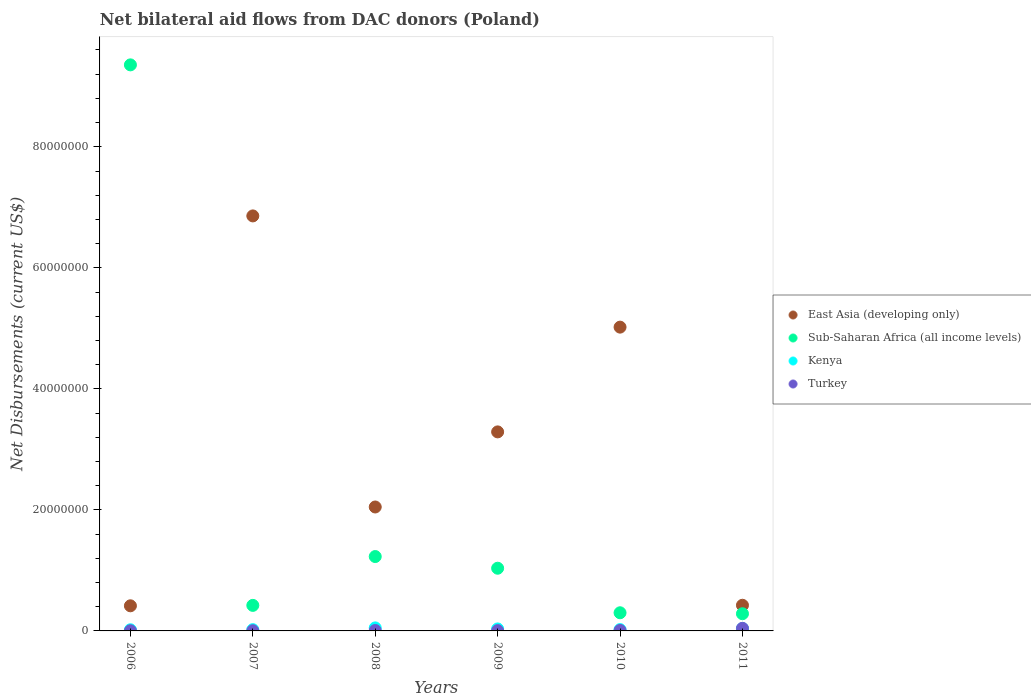How many different coloured dotlines are there?
Ensure brevity in your answer.  4. Is the number of dotlines equal to the number of legend labels?
Make the answer very short. Yes. What is the net bilateral aid flows in Turkey in 2011?
Provide a succinct answer. 4.30e+05. Across all years, what is the maximum net bilateral aid flows in Kenya?
Give a very brief answer. 5.00e+05. Across all years, what is the minimum net bilateral aid flows in East Asia (developing only)?
Provide a succinct answer. 4.15e+06. In which year was the net bilateral aid flows in Kenya maximum?
Ensure brevity in your answer.  2008. In which year was the net bilateral aid flows in East Asia (developing only) minimum?
Give a very brief answer. 2006. What is the total net bilateral aid flows in Turkey in the graph?
Make the answer very short. 6.90e+05. What is the difference between the net bilateral aid flows in Kenya in 2006 and that in 2011?
Offer a very short reply. -2.10e+05. What is the difference between the net bilateral aid flows in Kenya in 2011 and the net bilateral aid flows in Sub-Saharan Africa (all income levels) in 2009?
Your response must be concise. -9.96e+06. What is the average net bilateral aid flows in East Asia (developing only) per year?
Offer a very short reply. 3.01e+07. In the year 2007, what is the difference between the net bilateral aid flows in Turkey and net bilateral aid flows in Sub-Saharan Africa (all income levels)?
Your answer should be very brief. -4.19e+06. In how many years, is the net bilateral aid flows in Kenya greater than 20000000 US$?
Ensure brevity in your answer.  0. What is the ratio of the net bilateral aid flows in Kenya in 2006 to that in 2010?
Offer a terse response. 0.86. Is the net bilateral aid flows in Kenya in 2007 less than that in 2008?
Ensure brevity in your answer.  Yes. What is the difference between the highest and the lowest net bilateral aid flows in Kenya?
Ensure brevity in your answer.  3.10e+05. In how many years, is the net bilateral aid flows in Sub-Saharan Africa (all income levels) greater than the average net bilateral aid flows in Sub-Saharan Africa (all income levels) taken over all years?
Provide a succinct answer. 1. Is the sum of the net bilateral aid flows in Kenya in 2008 and 2009 greater than the maximum net bilateral aid flows in Turkey across all years?
Provide a succinct answer. Yes. Is the net bilateral aid flows in Kenya strictly less than the net bilateral aid flows in East Asia (developing only) over the years?
Provide a succinct answer. Yes. How many dotlines are there?
Provide a short and direct response. 4. How many years are there in the graph?
Ensure brevity in your answer.  6. Are the values on the major ticks of Y-axis written in scientific E-notation?
Give a very brief answer. No. Does the graph contain grids?
Your answer should be compact. No. Where does the legend appear in the graph?
Your answer should be very brief. Center right. What is the title of the graph?
Offer a very short reply. Net bilateral aid flows from DAC donors (Poland). What is the label or title of the X-axis?
Make the answer very short. Years. What is the label or title of the Y-axis?
Make the answer very short. Net Disbursements (current US$). What is the Net Disbursements (current US$) of East Asia (developing only) in 2006?
Keep it short and to the point. 4.15e+06. What is the Net Disbursements (current US$) in Sub-Saharan Africa (all income levels) in 2006?
Make the answer very short. 9.35e+07. What is the Net Disbursements (current US$) of Turkey in 2006?
Your response must be concise. 3.00e+04. What is the Net Disbursements (current US$) of East Asia (developing only) in 2007?
Give a very brief answer. 6.86e+07. What is the Net Disbursements (current US$) of Sub-Saharan Africa (all income levels) in 2007?
Keep it short and to the point. 4.22e+06. What is the Net Disbursements (current US$) of East Asia (developing only) in 2008?
Ensure brevity in your answer.  2.05e+07. What is the Net Disbursements (current US$) in Sub-Saharan Africa (all income levels) in 2008?
Offer a very short reply. 1.23e+07. What is the Net Disbursements (current US$) of Kenya in 2008?
Keep it short and to the point. 5.00e+05. What is the Net Disbursements (current US$) in Turkey in 2008?
Provide a short and direct response. 7.00e+04. What is the Net Disbursements (current US$) in East Asia (developing only) in 2009?
Keep it short and to the point. 3.29e+07. What is the Net Disbursements (current US$) in Sub-Saharan Africa (all income levels) in 2009?
Your response must be concise. 1.04e+07. What is the Net Disbursements (current US$) in Kenya in 2009?
Your answer should be compact. 3.30e+05. What is the Net Disbursements (current US$) of East Asia (developing only) in 2010?
Provide a succinct answer. 5.02e+07. What is the Net Disbursements (current US$) of Kenya in 2010?
Offer a very short reply. 2.20e+05. What is the Net Disbursements (current US$) of Turkey in 2010?
Keep it short and to the point. 8.00e+04. What is the Net Disbursements (current US$) of East Asia (developing only) in 2011?
Give a very brief answer. 4.24e+06. What is the Net Disbursements (current US$) of Sub-Saharan Africa (all income levels) in 2011?
Give a very brief answer. 2.84e+06. Across all years, what is the maximum Net Disbursements (current US$) of East Asia (developing only)?
Offer a terse response. 6.86e+07. Across all years, what is the maximum Net Disbursements (current US$) in Sub-Saharan Africa (all income levels)?
Give a very brief answer. 9.35e+07. Across all years, what is the maximum Net Disbursements (current US$) in Kenya?
Your answer should be very brief. 5.00e+05. Across all years, what is the maximum Net Disbursements (current US$) in Turkey?
Your response must be concise. 4.30e+05. Across all years, what is the minimum Net Disbursements (current US$) in East Asia (developing only)?
Give a very brief answer. 4.15e+06. Across all years, what is the minimum Net Disbursements (current US$) in Sub-Saharan Africa (all income levels)?
Offer a very short reply. 2.84e+06. Across all years, what is the minimum Net Disbursements (current US$) in Turkey?
Give a very brief answer. 3.00e+04. What is the total Net Disbursements (current US$) in East Asia (developing only) in the graph?
Your answer should be compact. 1.81e+08. What is the total Net Disbursements (current US$) in Sub-Saharan Africa (all income levels) in the graph?
Provide a short and direct response. 1.26e+08. What is the total Net Disbursements (current US$) in Kenya in the graph?
Offer a terse response. 1.85e+06. What is the total Net Disbursements (current US$) of Turkey in the graph?
Your response must be concise. 6.90e+05. What is the difference between the Net Disbursements (current US$) of East Asia (developing only) in 2006 and that in 2007?
Your answer should be very brief. -6.44e+07. What is the difference between the Net Disbursements (current US$) in Sub-Saharan Africa (all income levels) in 2006 and that in 2007?
Keep it short and to the point. 8.93e+07. What is the difference between the Net Disbursements (current US$) in Turkey in 2006 and that in 2007?
Make the answer very short. 0. What is the difference between the Net Disbursements (current US$) in East Asia (developing only) in 2006 and that in 2008?
Keep it short and to the point. -1.63e+07. What is the difference between the Net Disbursements (current US$) in Sub-Saharan Africa (all income levels) in 2006 and that in 2008?
Keep it short and to the point. 8.12e+07. What is the difference between the Net Disbursements (current US$) in Kenya in 2006 and that in 2008?
Make the answer very short. -3.10e+05. What is the difference between the Net Disbursements (current US$) of Turkey in 2006 and that in 2008?
Ensure brevity in your answer.  -4.00e+04. What is the difference between the Net Disbursements (current US$) in East Asia (developing only) in 2006 and that in 2009?
Your answer should be compact. -2.87e+07. What is the difference between the Net Disbursements (current US$) in Sub-Saharan Africa (all income levels) in 2006 and that in 2009?
Ensure brevity in your answer.  8.32e+07. What is the difference between the Net Disbursements (current US$) in Kenya in 2006 and that in 2009?
Your answer should be very brief. -1.40e+05. What is the difference between the Net Disbursements (current US$) of East Asia (developing only) in 2006 and that in 2010?
Offer a very short reply. -4.60e+07. What is the difference between the Net Disbursements (current US$) in Sub-Saharan Africa (all income levels) in 2006 and that in 2010?
Your answer should be compact. 9.05e+07. What is the difference between the Net Disbursements (current US$) of Turkey in 2006 and that in 2010?
Keep it short and to the point. -5.00e+04. What is the difference between the Net Disbursements (current US$) of Sub-Saharan Africa (all income levels) in 2006 and that in 2011?
Give a very brief answer. 9.07e+07. What is the difference between the Net Disbursements (current US$) of Kenya in 2006 and that in 2011?
Give a very brief answer. -2.10e+05. What is the difference between the Net Disbursements (current US$) of Turkey in 2006 and that in 2011?
Your answer should be very brief. -4.00e+05. What is the difference between the Net Disbursements (current US$) of East Asia (developing only) in 2007 and that in 2008?
Provide a succinct answer. 4.81e+07. What is the difference between the Net Disbursements (current US$) in Sub-Saharan Africa (all income levels) in 2007 and that in 2008?
Keep it short and to the point. -8.07e+06. What is the difference between the Net Disbursements (current US$) of Turkey in 2007 and that in 2008?
Keep it short and to the point. -4.00e+04. What is the difference between the Net Disbursements (current US$) in East Asia (developing only) in 2007 and that in 2009?
Provide a succinct answer. 3.57e+07. What is the difference between the Net Disbursements (current US$) in Sub-Saharan Africa (all income levels) in 2007 and that in 2009?
Give a very brief answer. -6.14e+06. What is the difference between the Net Disbursements (current US$) in Turkey in 2007 and that in 2009?
Keep it short and to the point. -2.00e+04. What is the difference between the Net Disbursements (current US$) in East Asia (developing only) in 2007 and that in 2010?
Your response must be concise. 1.84e+07. What is the difference between the Net Disbursements (current US$) in Sub-Saharan Africa (all income levels) in 2007 and that in 2010?
Your answer should be very brief. 1.22e+06. What is the difference between the Net Disbursements (current US$) of Kenya in 2007 and that in 2010?
Provide a succinct answer. -10000. What is the difference between the Net Disbursements (current US$) of Turkey in 2007 and that in 2010?
Provide a short and direct response. -5.00e+04. What is the difference between the Net Disbursements (current US$) of East Asia (developing only) in 2007 and that in 2011?
Offer a terse response. 6.43e+07. What is the difference between the Net Disbursements (current US$) of Sub-Saharan Africa (all income levels) in 2007 and that in 2011?
Your response must be concise. 1.38e+06. What is the difference between the Net Disbursements (current US$) of Kenya in 2007 and that in 2011?
Your answer should be compact. -1.90e+05. What is the difference between the Net Disbursements (current US$) of Turkey in 2007 and that in 2011?
Provide a short and direct response. -4.00e+05. What is the difference between the Net Disbursements (current US$) of East Asia (developing only) in 2008 and that in 2009?
Keep it short and to the point. -1.24e+07. What is the difference between the Net Disbursements (current US$) of Sub-Saharan Africa (all income levels) in 2008 and that in 2009?
Your answer should be compact. 1.93e+06. What is the difference between the Net Disbursements (current US$) in East Asia (developing only) in 2008 and that in 2010?
Make the answer very short. -2.97e+07. What is the difference between the Net Disbursements (current US$) of Sub-Saharan Africa (all income levels) in 2008 and that in 2010?
Your answer should be compact. 9.29e+06. What is the difference between the Net Disbursements (current US$) of East Asia (developing only) in 2008 and that in 2011?
Ensure brevity in your answer.  1.62e+07. What is the difference between the Net Disbursements (current US$) in Sub-Saharan Africa (all income levels) in 2008 and that in 2011?
Your answer should be very brief. 9.45e+06. What is the difference between the Net Disbursements (current US$) in Kenya in 2008 and that in 2011?
Offer a very short reply. 1.00e+05. What is the difference between the Net Disbursements (current US$) in Turkey in 2008 and that in 2011?
Offer a very short reply. -3.60e+05. What is the difference between the Net Disbursements (current US$) of East Asia (developing only) in 2009 and that in 2010?
Keep it short and to the point. -1.73e+07. What is the difference between the Net Disbursements (current US$) in Sub-Saharan Africa (all income levels) in 2009 and that in 2010?
Offer a terse response. 7.36e+06. What is the difference between the Net Disbursements (current US$) of Kenya in 2009 and that in 2010?
Keep it short and to the point. 1.10e+05. What is the difference between the Net Disbursements (current US$) in Turkey in 2009 and that in 2010?
Offer a terse response. -3.00e+04. What is the difference between the Net Disbursements (current US$) of East Asia (developing only) in 2009 and that in 2011?
Provide a short and direct response. 2.86e+07. What is the difference between the Net Disbursements (current US$) in Sub-Saharan Africa (all income levels) in 2009 and that in 2011?
Give a very brief answer. 7.52e+06. What is the difference between the Net Disbursements (current US$) of Turkey in 2009 and that in 2011?
Give a very brief answer. -3.80e+05. What is the difference between the Net Disbursements (current US$) of East Asia (developing only) in 2010 and that in 2011?
Offer a terse response. 4.60e+07. What is the difference between the Net Disbursements (current US$) of Kenya in 2010 and that in 2011?
Provide a succinct answer. -1.80e+05. What is the difference between the Net Disbursements (current US$) of Turkey in 2010 and that in 2011?
Your answer should be compact. -3.50e+05. What is the difference between the Net Disbursements (current US$) in East Asia (developing only) in 2006 and the Net Disbursements (current US$) in Kenya in 2007?
Give a very brief answer. 3.94e+06. What is the difference between the Net Disbursements (current US$) of East Asia (developing only) in 2006 and the Net Disbursements (current US$) of Turkey in 2007?
Ensure brevity in your answer.  4.12e+06. What is the difference between the Net Disbursements (current US$) in Sub-Saharan Africa (all income levels) in 2006 and the Net Disbursements (current US$) in Kenya in 2007?
Offer a terse response. 9.33e+07. What is the difference between the Net Disbursements (current US$) in Sub-Saharan Africa (all income levels) in 2006 and the Net Disbursements (current US$) in Turkey in 2007?
Offer a terse response. 9.35e+07. What is the difference between the Net Disbursements (current US$) of Kenya in 2006 and the Net Disbursements (current US$) of Turkey in 2007?
Offer a very short reply. 1.60e+05. What is the difference between the Net Disbursements (current US$) of East Asia (developing only) in 2006 and the Net Disbursements (current US$) of Sub-Saharan Africa (all income levels) in 2008?
Offer a terse response. -8.14e+06. What is the difference between the Net Disbursements (current US$) of East Asia (developing only) in 2006 and the Net Disbursements (current US$) of Kenya in 2008?
Provide a succinct answer. 3.65e+06. What is the difference between the Net Disbursements (current US$) of East Asia (developing only) in 2006 and the Net Disbursements (current US$) of Turkey in 2008?
Your answer should be compact. 4.08e+06. What is the difference between the Net Disbursements (current US$) of Sub-Saharan Africa (all income levels) in 2006 and the Net Disbursements (current US$) of Kenya in 2008?
Ensure brevity in your answer.  9.30e+07. What is the difference between the Net Disbursements (current US$) in Sub-Saharan Africa (all income levels) in 2006 and the Net Disbursements (current US$) in Turkey in 2008?
Give a very brief answer. 9.35e+07. What is the difference between the Net Disbursements (current US$) in East Asia (developing only) in 2006 and the Net Disbursements (current US$) in Sub-Saharan Africa (all income levels) in 2009?
Provide a succinct answer. -6.21e+06. What is the difference between the Net Disbursements (current US$) in East Asia (developing only) in 2006 and the Net Disbursements (current US$) in Kenya in 2009?
Offer a terse response. 3.82e+06. What is the difference between the Net Disbursements (current US$) of East Asia (developing only) in 2006 and the Net Disbursements (current US$) of Turkey in 2009?
Your answer should be very brief. 4.10e+06. What is the difference between the Net Disbursements (current US$) in Sub-Saharan Africa (all income levels) in 2006 and the Net Disbursements (current US$) in Kenya in 2009?
Your response must be concise. 9.32e+07. What is the difference between the Net Disbursements (current US$) of Sub-Saharan Africa (all income levels) in 2006 and the Net Disbursements (current US$) of Turkey in 2009?
Ensure brevity in your answer.  9.35e+07. What is the difference between the Net Disbursements (current US$) of Kenya in 2006 and the Net Disbursements (current US$) of Turkey in 2009?
Keep it short and to the point. 1.40e+05. What is the difference between the Net Disbursements (current US$) of East Asia (developing only) in 2006 and the Net Disbursements (current US$) of Sub-Saharan Africa (all income levels) in 2010?
Provide a short and direct response. 1.15e+06. What is the difference between the Net Disbursements (current US$) of East Asia (developing only) in 2006 and the Net Disbursements (current US$) of Kenya in 2010?
Provide a short and direct response. 3.93e+06. What is the difference between the Net Disbursements (current US$) in East Asia (developing only) in 2006 and the Net Disbursements (current US$) in Turkey in 2010?
Offer a terse response. 4.07e+06. What is the difference between the Net Disbursements (current US$) in Sub-Saharan Africa (all income levels) in 2006 and the Net Disbursements (current US$) in Kenya in 2010?
Make the answer very short. 9.33e+07. What is the difference between the Net Disbursements (current US$) of Sub-Saharan Africa (all income levels) in 2006 and the Net Disbursements (current US$) of Turkey in 2010?
Give a very brief answer. 9.35e+07. What is the difference between the Net Disbursements (current US$) in Kenya in 2006 and the Net Disbursements (current US$) in Turkey in 2010?
Ensure brevity in your answer.  1.10e+05. What is the difference between the Net Disbursements (current US$) in East Asia (developing only) in 2006 and the Net Disbursements (current US$) in Sub-Saharan Africa (all income levels) in 2011?
Keep it short and to the point. 1.31e+06. What is the difference between the Net Disbursements (current US$) of East Asia (developing only) in 2006 and the Net Disbursements (current US$) of Kenya in 2011?
Your answer should be compact. 3.75e+06. What is the difference between the Net Disbursements (current US$) of East Asia (developing only) in 2006 and the Net Disbursements (current US$) of Turkey in 2011?
Offer a terse response. 3.72e+06. What is the difference between the Net Disbursements (current US$) in Sub-Saharan Africa (all income levels) in 2006 and the Net Disbursements (current US$) in Kenya in 2011?
Your answer should be compact. 9.31e+07. What is the difference between the Net Disbursements (current US$) in Sub-Saharan Africa (all income levels) in 2006 and the Net Disbursements (current US$) in Turkey in 2011?
Offer a terse response. 9.31e+07. What is the difference between the Net Disbursements (current US$) in East Asia (developing only) in 2007 and the Net Disbursements (current US$) in Sub-Saharan Africa (all income levels) in 2008?
Ensure brevity in your answer.  5.63e+07. What is the difference between the Net Disbursements (current US$) of East Asia (developing only) in 2007 and the Net Disbursements (current US$) of Kenya in 2008?
Offer a terse response. 6.81e+07. What is the difference between the Net Disbursements (current US$) in East Asia (developing only) in 2007 and the Net Disbursements (current US$) in Turkey in 2008?
Your answer should be very brief. 6.85e+07. What is the difference between the Net Disbursements (current US$) of Sub-Saharan Africa (all income levels) in 2007 and the Net Disbursements (current US$) of Kenya in 2008?
Provide a short and direct response. 3.72e+06. What is the difference between the Net Disbursements (current US$) in Sub-Saharan Africa (all income levels) in 2007 and the Net Disbursements (current US$) in Turkey in 2008?
Keep it short and to the point. 4.15e+06. What is the difference between the Net Disbursements (current US$) of East Asia (developing only) in 2007 and the Net Disbursements (current US$) of Sub-Saharan Africa (all income levels) in 2009?
Ensure brevity in your answer.  5.82e+07. What is the difference between the Net Disbursements (current US$) of East Asia (developing only) in 2007 and the Net Disbursements (current US$) of Kenya in 2009?
Ensure brevity in your answer.  6.82e+07. What is the difference between the Net Disbursements (current US$) of East Asia (developing only) in 2007 and the Net Disbursements (current US$) of Turkey in 2009?
Offer a terse response. 6.85e+07. What is the difference between the Net Disbursements (current US$) in Sub-Saharan Africa (all income levels) in 2007 and the Net Disbursements (current US$) in Kenya in 2009?
Make the answer very short. 3.89e+06. What is the difference between the Net Disbursements (current US$) in Sub-Saharan Africa (all income levels) in 2007 and the Net Disbursements (current US$) in Turkey in 2009?
Your response must be concise. 4.17e+06. What is the difference between the Net Disbursements (current US$) in Kenya in 2007 and the Net Disbursements (current US$) in Turkey in 2009?
Keep it short and to the point. 1.60e+05. What is the difference between the Net Disbursements (current US$) in East Asia (developing only) in 2007 and the Net Disbursements (current US$) in Sub-Saharan Africa (all income levels) in 2010?
Offer a terse response. 6.56e+07. What is the difference between the Net Disbursements (current US$) of East Asia (developing only) in 2007 and the Net Disbursements (current US$) of Kenya in 2010?
Offer a very short reply. 6.84e+07. What is the difference between the Net Disbursements (current US$) of East Asia (developing only) in 2007 and the Net Disbursements (current US$) of Turkey in 2010?
Keep it short and to the point. 6.85e+07. What is the difference between the Net Disbursements (current US$) of Sub-Saharan Africa (all income levels) in 2007 and the Net Disbursements (current US$) of Kenya in 2010?
Offer a terse response. 4.00e+06. What is the difference between the Net Disbursements (current US$) of Sub-Saharan Africa (all income levels) in 2007 and the Net Disbursements (current US$) of Turkey in 2010?
Offer a very short reply. 4.14e+06. What is the difference between the Net Disbursements (current US$) in East Asia (developing only) in 2007 and the Net Disbursements (current US$) in Sub-Saharan Africa (all income levels) in 2011?
Offer a terse response. 6.57e+07. What is the difference between the Net Disbursements (current US$) in East Asia (developing only) in 2007 and the Net Disbursements (current US$) in Kenya in 2011?
Keep it short and to the point. 6.82e+07. What is the difference between the Net Disbursements (current US$) of East Asia (developing only) in 2007 and the Net Disbursements (current US$) of Turkey in 2011?
Keep it short and to the point. 6.82e+07. What is the difference between the Net Disbursements (current US$) in Sub-Saharan Africa (all income levels) in 2007 and the Net Disbursements (current US$) in Kenya in 2011?
Give a very brief answer. 3.82e+06. What is the difference between the Net Disbursements (current US$) in Sub-Saharan Africa (all income levels) in 2007 and the Net Disbursements (current US$) in Turkey in 2011?
Your answer should be compact. 3.79e+06. What is the difference between the Net Disbursements (current US$) in Kenya in 2007 and the Net Disbursements (current US$) in Turkey in 2011?
Give a very brief answer. -2.20e+05. What is the difference between the Net Disbursements (current US$) in East Asia (developing only) in 2008 and the Net Disbursements (current US$) in Sub-Saharan Africa (all income levels) in 2009?
Provide a short and direct response. 1.01e+07. What is the difference between the Net Disbursements (current US$) of East Asia (developing only) in 2008 and the Net Disbursements (current US$) of Kenya in 2009?
Offer a very short reply. 2.02e+07. What is the difference between the Net Disbursements (current US$) in East Asia (developing only) in 2008 and the Net Disbursements (current US$) in Turkey in 2009?
Ensure brevity in your answer.  2.04e+07. What is the difference between the Net Disbursements (current US$) of Sub-Saharan Africa (all income levels) in 2008 and the Net Disbursements (current US$) of Kenya in 2009?
Your answer should be compact. 1.20e+07. What is the difference between the Net Disbursements (current US$) of Sub-Saharan Africa (all income levels) in 2008 and the Net Disbursements (current US$) of Turkey in 2009?
Provide a succinct answer. 1.22e+07. What is the difference between the Net Disbursements (current US$) of Kenya in 2008 and the Net Disbursements (current US$) of Turkey in 2009?
Your answer should be compact. 4.50e+05. What is the difference between the Net Disbursements (current US$) in East Asia (developing only) in 2008 and the Net Disbursements (current US$) in Sub-Saharan Africa (all income levels) in 2010?
Give a very brief answer. 1.75e+07. What is the difference between the Net Disbursements (current US$) of East Asia (developing only) in 2008 and the Net Disbursements (current US$) of Kenya in 2010?
Your response must be concise. 2.03e+07. What is the difference between the Net Disbursements (current US$) of East Asia (developing only) in 2008 and the Net Disbursements (current US$) of Turkey in 2010?
Provide a short and direct response. 2.04e+07. What is the difference between the Net Disbursements (current US$) in Sub-Saharan Africa (all income levels) in 2008 and the Net Disbursements (current US$) in Kenya in 2010?
Provide a short and direct response. 1.21e+07. What is the difference between the Net Disbursements (current US$) of Sub-Saharan Africa (all income levels) in 2008 and the Net Disbursements (current US$) of Turkey in 2010?
Keep it short and to the point. 1.22e+07. What is the difference between the Net Disbursements (current US$) of Kenya in 2008 and the Net Disbursements (current US$) of Turkey in 2010?
Your answer should be compact. 4.20e+05. What is the difference between the Net Disbursements (current US$) in East Asia (developing only) in 2008 and the Net Disbursements (current US$) in Sub-Saharan Africa (all income levels) in 2011?
Offer a terse response. 1.76e+07. What is the difference between the Net Disbursements (current US$) in East Asia (developing only) in 2008 and the Net Disbursements (current US$) in Kenya in 2011?
Offer a very short reply. 2.01e+07. What is the difference between the Net Disbursements (current US$) of East Asia (developing only) in 2008 and the Net Disbursements (current US$) of Turkey in 2011?
Your answer should be very brief. 2.00e+07. What is the difference between the Net Disbursements (current US$) in Sub-Saharan Africa (all income levels) in 2008 and the Net Disbursements (current US$) in Kenya in 2011?
Give a very brief answer. 1.19e+07. What is the difference between the Net Disbursements (current US$) in Sub-Saharan Africa (all income levels) in 2008 and the Net Disbursements (current US$) in Turkey in 2011?
Your answer should be very brief. 1.19e+07. What is the difference between the Net Disbursements (current US$) of Kenya in 2008 and the Net Disbursements (current US$) of Turkey in 2011?
Your answer should be very brief. 7.00e+04. What is the difference between the Net Disbursements (current US$) of East Asia (developing only) in 2009 and the Net Disbursements (current US$) of Sub-Saharan Africa (all income levels) in 2010?
Your response must be concise. 2.99e+07. What is the difference between the Net Disbursements (current US$) in East Asia (developing only) in 2009 and the Net Disbursements (current US$) in Kenya in 2010?
Your response must be concise. 3.27e+07. What is the difference between the Net Disbursements (current US$) of East Asia (developing only) in 2009 and the Net Disbursements (current US$) of Turkey in 2010?
Your answer should be compact. 3.28e+07. What is the difference between the Net Disbursements (current US$) in Sub-Saharan Africa (all income levels) in 2009 and the Net Disbursements (current US$) in Kenya in 2010?
Ensure brevity in your answer.  1.01e+07. What is the difference between the Net Disbursements (current US$) of Sub-Saharan Africa (all income levels) in 2009 and the Net Disbursements (current US$) of Turkey in 2010?
Your response must be concise. 1.03e+07. What is the difference between the Net Disbursements (current US$) in Kenya in 2009 and the Net Disbursements (current US$) in Turkey in 2010?
Keep it short and to the point. 2.50e+05. What is the difference between the Net Disbursements (current US$) in East Asia (developing only) in 2009 and the Net Disbursements (current US$) in Sub-Saharan Africa (all income levels) in 2011?
Offer a terse response. 3.00e+07. What is the difference between the Net Disbursements (current US$) in East Asia (developing only) in 2009 and the Net Disbursements (current US$) in Kenya in 2011?
Your answer should be compact. 3.25e+07. What is the difference between the Net Disbursements (current US$) in East Asia (developing only) in 2009 and the Net Disbursements (current US$) in Turkey in 2011?
Offer a terse response. 3.25e+07. What is the difference between the Net Disbursements (current US$) in Sub-Saharan Africa (all income levels) in 2009 and the Net Disbursements (current US$) in Kenya in 2011?
Provide a succinct answer. 9.96e+06. What is the difference between the Net Disbursements (current US$) in Sub-Saharan Africa (all income levels) in 2009 and the Net Disbursements (current US$) in Turkey in 2011?
Offer a very short reply. 9.93e+06. What is the difference between the Net Disbursements (current US$) in Kenya in 2009 and the Net Disbursements (current US$) in Turkey in 2011?
Your response must be concise. -1.00e+05. What is the difference between the Net Disbursements (current US$) in East Asia (developing only) in 2010 and the Net Disbursements (current US$) in Sub-Saharan Africa (all income levels) in 2011?
Give a very brief answer. 4.74e+07. What is the difference between the Net Disbursements (current US$) of East Asia (developing only) in 2010 and the Net Disbursements (current US$) of Kenya in 2011?
Keep it short and to the point. 4.98e+07. What is the difference between the Net Disbursements (current US$) in East Asia (developing only) in 2010 and the Net Disbursements (current US$) in Turkey in 2011?
Give a very brief answer. 4.98e+07. What is the difference between the Net Disbursements (current US$) in Sub-Saharan Africa (all income levels) in 2010 and the Net Disbursements (current US$) in Kenya in 2011?
Your answer should be compact. 2.60e+06. What is the difference between the Net Disbursements (current US$) of Sub-Saharan Africa (all income levels) in 2010 and the Net Disbursements (current US$) of Turkey in 2011?
Provide a short and direct response. 2.57e+06. What is the average Net Disbursements (current US$) of East Asia (developing only) per year?
Your response must be concise. 3.01e+07. What is the average Net Disbursements (current US$) of Sub-Saharan Africa (all income levels) per year?
Provide a succinct answer. 2.10e+07. What is the average Net Disbursements (current US$) of Kenya per year?
Your response must be concise. 3.08e+05. What is the average Net Disbursements (current US$) of Turkey per year?
Offer a terse response. 1.15e+05. In the year 2006, what is the difference between the Net Disbursements (current US$) in East Asia (developing only) and Net Disbursements (current US$) in Sub-Saharan Africa (all income levels)?
Your response must be concise. -8.94e+07. In the year 2006, what is the difference between the Net Disbursements (current US$) in East Asia (developing only) and Net Disbursements (current US$) in Kenya?
Your response must be concise. 3.96e+06. In the year 2006, what is the difference between the Net Disbursements (current US$) in East Asia (developing only) and Net Disbursements (current US$) in Turkey?
Your answer should be very brief. 4.12e+06. In the year 2006, what is the difference between the Net Disbursements (current US$) in Sub-Saharan Africa (all income levels) and Net Disbursements (current US$) in Kenya?
Make the answer very short. 9.34e+07. In the year 2006, what is the difference between the Net Disbursements (current US$) in Sub-Saharan Africa (all income levels) and Net Disbursements (current US$) in Turkey?
Give a very brief answer. 9.35e+07. In the year 2007, what is the difference between the Net Disbursements (current US$) of East Asia (developing only) and Net Disbursements (current US$) of Sub-Saharan Africa (all income levels)?
Offer a very short reply. 6.44e+07. In the year 2007, what is the difference between the Net Disbursements (current US$) in East Asia (developing only) and Net Disbursements (current US$) in Kenya?
Keep it short and to the point. 6.84e+07. In the year 2007, what is the difference between the Net Disbursements (current US$) in East Asia (developing only) and Net Disbursements (current US$) in Turkey?
Offer a terse response. 6.86e+07. In the year 2007, what is the difference between the Net Disbursements (current US$) of Sub-Saharan Africa (all income levels) and Net Disbursements (current US$) of Kenya?
Ensure brevity in your answer.  4.01e+06. In the year 2007, what is the difference between the Net Disbursements (current US$) of Sub-Saharan Africa (all income levels) and Net Disbursements (current US$) of Turkey?
Offer a terse response. 4.19e+06. In the year 2008, what is the difference between the Net Disbursements (current US$) in East Asia (developing only) and Net Disbursements (current US$) in Sub-Saharan Africa (all income levels)?
Provide a short and direct response. 8.19e+06. In the year 2008, what is the difference between the Net Disbursements (current US$) in East Asia (developing only) and Net Disbursements (current US$) in Kenya?
Your response must be concise. 2.00e+07. In the year 2008, what is the difference between the Net Disbursements (current US$) in East Asia (developing only) and Net Disbursements (current US$) in Turkey?
Your answer should be very brief. 2.04e+07. In the year 2008, what is the difference between the Net Disbursements (current US$) of Sub-Saharan Africa (all income levels) and Net Disbursements (current US$) of Kenya?
Offer a very short reply. 1.18e+07. In the year 2008, what is the difference between the Net Disbursements (current US$) in Sub-Saharan Africa (all income levels) and Net Disbursements (current US$) in Turkey?
Offer a very short reply. 1.22e+07. In the year 2008, what is the difference between the Net Disbursements (current US$) of Kenya and Net Disbursements (current US$) of Turkey?
Provide a short and direct response. 4.30e+05. In the year 2009, what is the difference between the Net Disbursements (current US$) of East Asia (developing only) and Net Disbursements (current US$) of Sub-Saharan Africa (all income levels)?
Provide a short and direct response. 2.25e+07. In the year 2009, what is the difference between the Net Disbursements (current US$) of East Asia (developing only) and Net Disbursements (current US$) of Kenya?
Make the answer very short. 3.26e+07. In the year 2009, what is the difference between the Net Disbursements (current US$) of East Asia (developing only) and Net Disbursements (current US$) of Turkey?
Offer a terse response. 3.28e+07. In the year 2009, what is the difference between the Net Disbursements (current US$) in Sub-Saharan Africa (all income levels) and Net Disbursements (current US$) in Kenya?
Provide a short and direct response. 1.00e+07. In the year 2009, what is the difference between the Net Disbursements (current US$) in Sub-Saharan Africa (all income levels) and Net Disbursements (current US$) in Turkey?
Provide a short and direct response. 1.03e+07. In the year 2010, what is the difference between the Net Disbursements (current US$) in East Asia (developing only) and Net Disbursements (current US$) in Sub-Saharan Africa (all income levels)?
Make the answer very short. 4.72e+07. In the year 2010, what is the difference between the Net Disbursements (current US$) in East Asia (developing only) and Net Disbursements (current US$) in Kenya?
Ensure brevity in your answer.  5.00e+07. In the year 2010, what is the difference between the Net Disbursements (current US$) in East Asia (developing only) and Net Disbursements (current US$) in Turkey?
Your answer should be very brief. 5.01e+07. In the year 2010, what is the difference between the Net Disbursements (current US$) of Sub-Saharan Africa (all income levels) and Net Disbursements (current US$) of Kenya?
Provide a short and direct response. 2.78e+06. In the year 2010, what is the difference between the Net Disbursements (current US$) of Sub-Saharan Africa (all income levels) and Net Disbursements (current US$) of Turkey?
Offer a terse response. 2.92e+06. In the year 2010, what is the difference between the Net Disbursements (current US$) of Kenya and Net Disbursements (current US$) of Turkey?
Make the answer very short. 1.40e+05. In the year 2011, what is the difference between the Net Disbursements (current US$) in East Asia (developing only) and Net Disbursements (current US$) in Sub-Saharan Africa (all income levels)?
Provide a short and direct response. 1.40e+06. In the year 2011, what is the difference between the Net Disbursements (current US$) of East Asia (developing only) and Net Disbursements (current US$) of Kenya?
Offer a very short reply. 3.84e+06. In the year 2011, what is the difference between the Net Disbursements (current US$) in East Asia (developing only) and Net Disbursements (current US$) in Turkey?
Give a very brief answer. 3.81e+06. In the year 2011, what is the difference between the Net Disbursements (current US$) in Sub-Saharan Africa (all income levels) and Net Disbursements (current US$) in Kenya?
Provide a short and direct response. 2.44e+06. In the year 2011, what is the difference between the Net Disbursements (current US$) in Sub-Saharan Africa (all income levels) and Net Disbursements (current US$) in Turkey?
Provide a short and direct response. 2.41e+06. In the year 2011, what is the difference between the Net Disbursements (current US$) in Kenya and Net Disbursements (current US$) in Turkey?
Provide a short and direct response. -3.00e+04. What is the ratio of the Net Disbursements (current US$) in East Asia (developing only) in 2006 to that in 2007?
Give a very brief answer. 0.06. What is the ratio of the Net Disbursements (current US$) in Sub-Saharan Africa (all income levels) in 2006 to that in 2007?
Your response must be concise. 22.17. What is the ratio of the Net Disbursements (current US$) in Kenya in 2006 to that in 2007?
Give a very brief answer. 0.9. What is the ratio of the Net Disbursements (current US$) of East Asia (developing only) in 2006 to that in 2008?
Your response must be concise. 0.2. What is the ratio of the Net Disbursements (current US$) in Sub-Saharan Africa (all income levels) in 2006 to that in 2008?
Offer a terse response. 7.61. What is the ratio of the Net Disbursements (current US$) of Kenya in 2006 to that in 2008?
Your answer should be compact. 0.38. What is the ratio of the Net Disbursements (current US$) of Turkey in 2006 to that in 2008?
Make the answer very short. 0.43. What is the ratio of the Net Disbursements (current US$) in East Asia (developing only) in 2006 to that in 2009?
Your answer should be compact. 0.13. What is the ratio of the Net Disbursements (current US$) of Sub-Saharan Africa (all income levels) in 2006 to that in 2009?
Your answer should be compact. 9.03. What is the ratio of the Net Disbursements (current US$) of Kenya in 2006 to that in 2009?
Your answer should be compact. 0.58. What is the ratio of the Net Disbursements (current US$) in East Asia (developing only) in 2006 to that in 2010?
Your answer should be very brief. 0.08. What is the ratio of the Net Disbursements (current US$) in Sub-Saharan Africa (all income levels) in 2006 to that in 2010?
Give a very brief answer. 31.18. What is the ratio of the Net Disbursements (current US$) in Kenya in 2006 to that in 2010?
Offer a terse response. 0.86. What is the ratio of the Net Disbursements (current US$) of Turkey in 2006 to that in 2010?
Your answer should be compact. 0.38. What is the ratio of the Net Disbursements (current US$) of East Asia (developing only) in 2006 to that in 2011?
Offer a very short reply. 0.98. What is the ratio of the Net Disbursements (current US$) of Sub-Saharan Africa (all income levels) in 2006 to that in 2011?
Give a very brief answer. 32.94. What is the ratio of the Net Disbursements (current US$) in Kenya in 2006 to that in 2011?
Offer a very short reply. 0.47. What is the ratio of the Net Disbursements (current US$) of Turkey in 2006 to that in 2011?
Ensure brevity in your answer.  0.07. What is the ratio of the Net Disbursements (current US$) in East Asia (developing only) in 2007 to that in 2008?
Provide a short and direct response. 3.35. What is the ratio of the Net Disbursements (current US$) in Sub-Saharan Africa (all income levels) in 2007 to that in 2008?
Make the answer very short. 0.34. What is the ratio of the Net Disbursements (current US$) in Kenya in 2007 to that in 2008?
Provide a succinct answer. 0.42. What is the ratio of the Net Disbursements (current US$) of Turkey in 2007 to that in 2008?
Offer a very short reply. 0.43. What is the ratio of the Net Disbursements (current US$) in East Asia (developing only) in 2007 to that in 2009?
Keep it short and to the point. 2.09. What is the ratio of the Net Disbursements (current US$) of Sub-Saharan Africa (all income levels) in 2007 to that in 2009?
Offer a very short reply. 0.41. What is the ratio of the Net Disbursements (current US$) in Kenya in 2007 to that in 2009?
Keep it short and to the point. 0.64. What is the ratio of the Net Disbursements (current US$) of Turkey in 2007 to that in 2009?
Give a very brief answer. 0.6. What is the ratio of the Net Disbursements (current US$) of East Asia (developing only) in 2007 to that in 2010?
Provide a short and direct response. 1.37. What is the ratio of the Net Disbursements (current US$) in Sub-Saharan Africa (all income levels) in 2007 to that in 2010?
Make the answer very short. 1.41. What is the ratio of the Net Disbursements (current US$) of Kenya in 2007 to that in 2010?
Your response must be concise. 0.95. What is the ratio of the Net Disbursements (current US$) of East Asia (developing only) in 2007 to that in 2011?
Give a very brief answer. 16.17. What is the ratio of the Net Disbursements (current US$) in Sub-Saharan Africa (all income levels) in 2007 to that in 2011?
Your response must be concise. 1.49. What is the ratio of the Net Disbursements (current US$) in Kenya in 2007 to that in 2011?
Make the answer very short. 0.53. What is the ratio of the Net Disbursements (current US$) in Turkey in 2007 to that in 2011?
Offer a very short reply. 0.07. What is the ratio of the Net Disbursements (current US$) of East Asia (developing only) in 2008 to that in 2009?
Your answer should be very brief. 0.62. What is the ratio of the Net Disbursements (current US$) in Sub-Saharan Africa (all income levels) in 2008 to that in 2009?
Your answer should be compact. 1.19. What is the ratio of the Net Disbursements (current US$) of Kenya in 2008 to that in 2009?
Offer a terse response. 1.52. What is the ratio of the Net Disbursements (current US$) in East Asia (developing only) in 2008 to that in 2010?
Keep it short and to the point. 0.41. What is the ratio of the Net Disbursements (current US$) of Sub-Saharan Africa (all income levels) in 2008 to that in 2010?
Keep it short and to the point. 4.1. What is the ratio of the Net Disbursements (current US$) in Kenya in 2008 to that in 2010?
Your response must be concise. 2.27. What is the ratio of the Net Disbursements (current US$) in Turkey in 2008 to that in 2010?
Your answer should be very brief. 0.88. What is the ratio of the Net Disbursements (current US$) in East Asia (developing only) in 2008 to that in 2011?
Offer a terse response. 4.83. What is the ratio of the Net Disbursements (current US$) of Sub-Saharan Africa (all income levels) in 2008 to that in 2011?
Your answer should be compact. 4.33. What is the ratio of the Net Disbursements (current US$) of Kenya in 2008 to that in 2011?
Give a very brief answer. 1.25. What is the ratio of the Net Disbursements (current US$) in Turkey in 2008 to that in 2011?
Keep it short and to the point. 0.16. What is the ratio of the Net Disbursements (current US$) in East Asia (developing only) in 2009 to that in 2010?
Your answer should be very brief. 0.66. What is the ratio of the Net Disbursements (current US$) of Sub-Saharan Africa (all income levels) in 2009 to that in 2010?
Offer a terse response. 3.45. What is the ratio of the Net Disbursements (current US$) in Kenya in 2009 to that in 2010?
Offer a terse response. 1.5. What is the ratio of the Net Disbursements (current US$) in Turkey in 2009 to that in 2010?
Give a very brief answer. 0.62. What is the ratio of the Net Disbursements (current US$) of East Asia (developing only) in 2009 to that in 2011?
Offer a very short reply. 7.76. What is the ratio of the Net Disbursements (current US$) of Sub-Saharan Africa (all income levels) in 2009 to that in 2011?
Offer a very short reply. 3.65. What is the ratio of the Net Disbursements (current US$) in Kenya in 2009 to that in 2011?
Offer a terse response. 0.82. What is the ratio of the Net Disbursements (current US$) in Turkey in 2009 to that in 2011?
Give a very brief answer. 0.12. What is the ratio of the Net Disbursements (current US$) in East Asia (developing only) in 2010 to that in 2011?
Ensure brevity in your answer.  11.84. What is the ratio of the Net Disbursements (current US$) of Sub-Saharan Africa (all income levels) in 2010 to that in 2011?
Offer a terse response. 1.06. What is the ratio of the Net Disbursements (current US$) of Kenya in 2010 to that in 2011?
Ensure brevity in your answer.  0.55. What is the ratio of the Net Disbursements (current US$) in Turkey in 2010 to that in 2011?
Provide a succinct answer. 0.19. What is the difference between the highest and the second highest Net Disbursements (current US$) in East Asia (developing only)?
Provide a succinct answer. 1.84e+07. What is the difference between the highest and the second highest Net Disbursements (current US$) of Sub-Saharan Africa (all income levels)?
Your answer should be compact. 8.12e+07. What is the difference between the highest and the lowest Net Disbursements (current US$) in East Asia (developing only)?
Provide a succinct answer. 6.44e+07. What is the difference between the highest and the lowest Net Disbursements (current US$) in Sub-Saharan Africa (all income levels)?
Your response must be concise. 9.07e+07. 